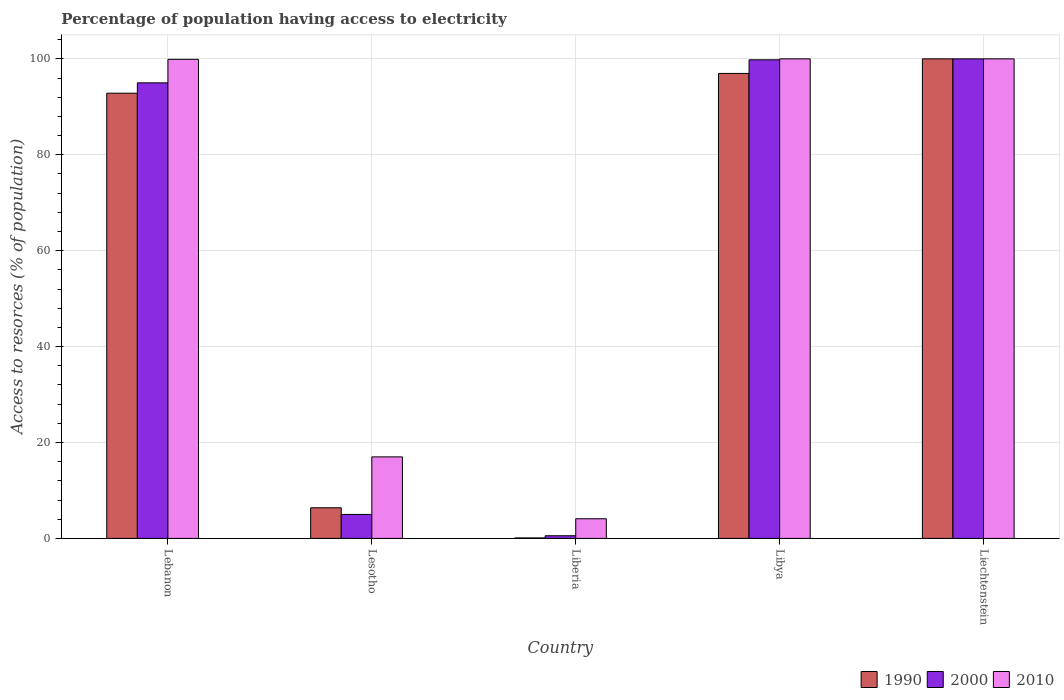How many different coloured bars are there?
Offer a terse response. 3. How many groups of bars are there?
Provide a short and direct response. 5. Are the number of bars per tick equal to the number of legend labels?
Your response must be concise. Yes. Are the number of bars on each tick of the X-axis equal?
Keep it short and to the point. Yes. How many bars are there on the 4th tick from the left?
Provide a succinct answer. 3. How many bars are there on the 4th tick from the right?
Keep it short and to the point. 3. What is the label of the 1st group of bars from the left?
Make the answer very short. Lebanon. What is the percentage of population having access to electricity in 1990 in Lesotho?
Offer a terse response. 6.39. Across all countries, what is the maximum percentage of population having access to electricity in 1990?
Keep it short and to the point. 100. Across all countries, what is the minimum percentage of population having access to electricity in 2010?
Make the answer very short. 4.1. In which country was the percentage of population having access to electricity in 1990 maximum?
Offer a very short reply. Liechtenstein. In which country was the percentage of population having access to electricity in 2000 minimum?
Provide a succinct answer. Liberia. What is the total percentage of population having access to electricity in 1990 in the graph?
Offer a terse response. 296.29. What is the difference between the percentage of population having access to electricity in 2010 in Lebanon and that in Lesotho?
Provide a succinct answer. 82.9. What is the average percentage of population having access to electricity in 1990 per country?
Provide a succinct answer. 59.26. What is the difference between the percentage of population having access to electricity of/in 1990 and percentage of population having access to electricity of/in 2000 in Lebanon?
Ensure brevity in your answer.  -2.16. In how many countries, is the percentage of population having access to electricity in 2000 greater than 56 %?
Provide a succinct answer. 3. What is the ratio of the percentage of population having access to electricity in 1990 in Lebanon to that in Lesotho?
Offer a very short reply. 14.53. Is the percentage of population having access to electricity in 2010 in Libya less than that in Liechtenstein?
Ensure brevity in your answer.  No. Is the difference between the percentage of population having access to electricity in 1990 in Lebanon and Lesotho greater than the difference between the percentage of population having access to electricity in 2000 in Lebanon and Lesotho?
Provide a short and direct response. No. What is the difference between the highest and the second highest percentage of population having access to electricity in 2010?
Make the answer very short. -0.1. What is the difference between the highest and the lowest percentage of population having access to electricity in 2010?
Your response must be concise. 95.9. Is the sum of the percentage of population having access to electricity in 1990 in Liberia and Libya greater than the maximum percentage of population having access to electricity in 2010 across all countries?
Provide a short and direct response. No. What does the 1st bar from the left in Lesotho represents?
Provide a succinct answer. 1990. What does the 2nd bar from the right in Liechtenstein represents?
Keep it short and to the point. 2000. Is it the case that in every country, the sum of the percentage of population having access to electricity in 1990 and percentage of population having access to electricity in 2000 is greater than the percentage of population having access to electricity in 2010?
Provide a short and direct response. No. How many bars are there?
Give a very brief answer. 15. Are all the bars in the graph horizontal?
Give a very brief answer. No. How many countries are there in the graph?
Your answer should be compact. 5. Are the values on the major ticks of Y-axis written in scientific E-notation?
Keep it short and to the point. No. How are the legend labels stacked?
Ensure brevity in your answer.  Horizontal. What is the title of the graph?
Ensure brevity in your answer.  Percentage of population having access to electricity. What is the label or title of the X-axis?
Give a very brief answer. Country. What is the label or title of the Y-axis?
Make the answer very short. Access to resorces (% of population). What is the Access to resorces (% of population) in 1990 in Lebanon?
Offer a terse response. 92.84. What is the Access to resorces (% of population) in 2010 in Lebanon?
Keep it short and to the point. 99.9. What is the Access to resorces (% of population) in 1990 in Lesotho?
Provide a succinct answer. 6.39. What is the Access to resorces (% of population) of 2000 in Lesotho?
Your response must be concise. 5. What is the Access to resorces (% of population) of 2010 in Lesotho?
Provide a short and direct response. 17. What is the Access to resorces (% of population) of 1990 in Liberia?
Your response must be concise. 0.1. What is the Access to resorces (% of population) of 2000 in Liberia?
Keep it short and to the point. 0.56. What is the Access to resorces (% of population) of 1990 in Libya?
Offer a very short reply. 96.96. What is the Access to resorces (% of population) in 2000 in Libya?
Your answer should be compact. 99.8. Across all countries, what is the maximum Access to resorces (% of population) in 1990?
Ensure brevity in your answer.  100. Across all countries, what is the minimum Access to resorces (% of population) of 1990?
Your answer should be compact. 0.1. Across all countries, what is the minimum Access to resorces (% of population) in 2000?
Provide a short and direct response. 0.56. Across all countries, what is the minimum Access to resorces (% of population) in 2010?
Offer a terse response. 4.1. What is the total Access to resorces (% of population) of 1990 in the graph?
Provide a succinct answer. 296.29. What is the total Access to resorces (% of population) of 2000 in the graph?
Your response must be concise. 300.36. What is the total Access to resorces (% of population) of 2010 in the graph?
Provide a short and direct response. 321. What is the difference between the Access to resorces (% of population) of 1990 in Lebanon and that in Lesotho?
Give a very brief answer. 86.45. What is the difference between the Access to resorces (% of population) in 2000 in Lebanon and that in Lesotho?
Your response must be concise. 90. What is the difference between the Access to resorces (% of population) of 2010 in Lebanon and that in Lesotho?
Ensure brevity in your answer.  82.9. What is the difference between the Access to resorces (% of population) in 1990 in Lebanon and that in Liberia?
Ensure brevity in your answer.  92.74. What is the difference between the Access to resorces (% of population) of 2000 in Lebanon and that in Liberia?
Give a very brief answer. 94.44. What is the difference between the Access to resorces (% of population) in 2010 in Lebanon and that in Liberia?
Your answer should be compact. 95.8. What is the difference between the Access to resorces (% of population) in 1990 in Lebanon and that in Libya?
Provide a short and direct response. -4.12. What is the difference between the Access to resorces (% of population) of 1990 in Lebanon and that in Liechtenstein?
Provide a short and direct response. -7.16. What is the difference between the Access to resorces (% of population) in 2000 in Lebanon and that in Liechtenstein?
Make the answer very short. -5. What is the difference between the Access to resorces (% of population) of 1990 in Lesotho and that in Liberia?
Your answer should be very brief. 6.29. What is the difference between the Access to resorces (% of population) of 2000 in Lesotho and that in Liberia?
Make the answer very short. 4.44. What is the difference between the Access to resorces (% of population) of 2010 in Lesotho and that in Liberia?
Your answer should be compact. 12.9. What is the difference between the Access to resorces (% of population) of 1990 in Lesotho and that in Libya?
Ensure brevity in your answer.  -90.57. What is the difference between the Access to resorces (% of population) of 2000 in Lesotho and that in Libya?
Offer a terse response. -94.8. What is the difference between the Access to resorces (% of population) of 2010 in Lesotho and that in Libya?
Your answer should be compact. -83. What is the difference between the Access to resorces (% of population) of 1990 in Lesotho and that in Liechtenstein?
Provide a short and direct response. -93.61. What is the difference between the Access to resorces (% of population) in 2000 in Lesotho and that in Liechtenstein?
Provide a short and direct response. -95. What is the difference between the Access to resorces (% of population) of 2010 in Lesotho and that in Liechtenstein?
Your answer should be very brief. -83. What is the difference between the Access to resorces (% of population) of 1990 in Liberia and that in Libya?
Ensure brevity in your answer.  -96.86. What is the difference between the Access to resorces (% of population) of 2000 in Liberia and that in Libya?
Provide a short and direct response. -99.24. What is the difference between the Access to resorces (% of population) of 2010 in Liberia and that in Libya?
Make the answer very short. -95.9. What is the difference between the Access to resorces (% of population) of 1990 in Liberia and that in Liechtenstein?
Ensure brevity in your answer.  -99.9. What is the difference between the Access to resorces (% of population) in 2000 in Liberia and that in Liechtenstein?
Provide a succinct answer. -99.44. What is the difference between the Access to resorces (% of population) in 2010 in Liberia and that in Liechtenstein?
Provide a short and direct response. -95.9. What is the difference between the Access to resorces (% of population) in 1990 in Libya and that in Liechtenstein?
Ensure brevity in your answer.  -3.04. What is the difference between the Access to resorces (% of population) in 2000 in Libya and that in Liechtenstein?
Offer a terse response. -0.2. What is the difference between the Access to resorces (% of population) of 2010 in Libya and that in Liechtenstein?
Your response must be concise. 0. What is the difference between the Access to resorces (% of population) in 1990 in Lebanon and the Access to resorces (% of population) in 2000 in Lesotho?
Your answer should be compact. 87.84. What is the difference between the Access to resorces (% of population) of 1990 in Lebanon and the Access to resorces (% of population) of 2010 in Lesotho?
Make the answer very short. 75.84. What is the difference between the Access to resorces (% of population) of 1990 in Lebanon and the Access to resorces (% of population) of 2000 in Liberia?
Keep it short and to the point. 92.28. What is the difference between the Access to resorces (% of population) of 1990 in Lebanon and the Access to resorces (% of population) of 2010 in Liberia?
Ensure brevity in your answer.  88.74. What is the difference between the Access to resorces (% of population) of 2000 in Lebanon and the Access to resorces (% of population) of 2010 in Liberia?
Provide a succinct answer. 90.9. What is the difference between the Access to resorces (% of population) of 1990 in Lebanon and the Access to resorces (% of population) of 2000 in Libya?
Your response must be concise. -6.96. What is the difference between the Access to resorces (% of population) in 1990 in Lebanon and the Access to resorces (% of population) in 2010 in Libya?
Offer a terse response. -7.16. What is the difference between the Access to resorces (% of population) of 1990 in Lebanon and the Access to resorces (% of population) of 2000 in Liechtenstein?
Your answer should be compact. -7.16. What is the difference between the Access to resorces (% of population) of 1990 in Lebanon and the Access to resorces (% of population) of 2010 in Liechtenstein?
Offer a terse response. -7.16. What is the difference between the Access to resorces (% of population) of 2000 in Lebanon and the Access to resorces (% of population) of 2010 in Liechtenstein?
Provide a short and direct response. -5. What is the difference between the Access to resorces (% of population) in 1990 in Lesotho and the Access to resorces (% of population) in 2000 in Liberia?
Provide a short and direct response. 5.83. What is the difference between the Access to resorces (% of population) of 1990 in Lesotho and the Access to resorces (% of population) of 2010 in Liberia?
Your response must be concise. 2.29. What is the difference between the Access to resorces (% of population) in 1990 in Lesotho and the Access to resorces (% of population) in 2000 in Libya?
Keep it short and to the point. -93.41. What is the difference between the Access to resorces (% of population) in 1990 in Lesotho and the Access to resorces (% of population) in 2010 in Libya?
Ensure brevity in your answer.  -93.61. What is the difference between the Access to resorces (% of population) of 2000 in Lesotho and the Access to resorces (% of population) of 2010 in Libya?
Your answer should be very brief. -95. What is the difference between the Access to resorces (% of population) in 1990 in Lesotho and the Access to resorces (% of population) in 2000 in Liechtenstein?
Give a very brief answer. -93.61. What is the difference between the Access to resorces (% of population) of 1990 in Lesotho and the Access to resorces (% of population) of 2010 in Liechtenstein?
Provide a short and direct response. -93.61. What is the difference between the Access to resorces (% of population) of 2000 in Lesotho and the Access to resorces (% of population) of 2010 in Liechtenstein?
Your response must be concise. -95. What is the difference between the Access to resorces (% of population) of 1990 in Liberia and the Access to resorces (% of population) of 2000 in Libya?
Provide a succinct answer. -99.7. What is the difference between the Access to resorces (% of population) in 1990 in Liberia and the Access to resorces (% of population) in 2010 in Libya?
Provide a short and direct response. -99.9. What is the difference between the Access to resorces (% of population) of 2000 in Liberia and the Access to resorces (% of population) of 2010 in Libya?
Provide a succinct answer. -99.44. What is the difference between the Access to resorces (% of population) of 1990 in Liberia and the Access to resorces (% of population) of 2000 in Liechtenstein?
Keep it short and to the point. -99.9. What is the difference between the Access to resorces (% of population) in 1990 in Liberia and the Access to resorces (% of population) in 2010 in Liechtenstein?
Your response must be concise. -99.9. What is the difference between the Access to resorces (% of population) of 2000 in Liberia and the Access to resorces (% of population) of 2010 in Liechtenstein?
Provide a succinct answer. -99.44. What is the difference between the Access to resorces (% of population) in 1990 in Libya and the Access to resorces (% of population) in 2000 in Liechtenstein?
Your answer should be very brief. -3.04. What is the difference between the Access to resorces (% of population) of 1990 in Libya and the Access to resorces (% of population) of 2010 in Liechtenstein?
Your answer should be very brief. -3.04. What is the average Access to resorces (% of population) in 1990 per country?
Offer a terse response. 59.26. What is the average Access to resorces (% of population) in 2000 per country?
Provide a short and direct response. 60.07. What is the average Access to resorces (% of population) of 2010 per country?
Keep it short and to the point. 64.2. What is the difference between the Access to resorces (% of population) of 1990 and Access to resorces (% of population) of 2000 in Lebanon?
Your answer should be compact. -2.16. What is the difference between the Access to resorces (% of population) of 1990 and Access to resorces (% of population) of 2010 in Lebanon?
Make the answer very short. -7.06. What is the difference between the Access to resorces (% of population) of 1990 and Access to resorces (% of population) of 2000 in Lesotho?
Provide a short and direct response. 1.39. What is the difference between the Access to resorces (% of population) of 1990 and Access to resorces (% of population) of 2010 in Lesotho?
Make the answer very short. -10.61. What is the difference between the Access to resorces (% of population) in 2000 and Access to resorces (% of population) in 2010 in Lesotho?
Keep it short and to the point. -12. What is the difference between the Access to resorces (% of population) in 1990 and Access to resorces (% of population) in 2000 in Liberia?
Give a very brief answer. -0.46. What is the difference between the Access to resorces (% of population) of 1990 and Access to resorces (% of population) of 2010 in Liberia?
Ensure brevity in your answer.  -4. What is the difference between the Access to resorces (% of population) in 2000 and Access to resorces (% of population) in 2010 in Liberia?
Keep it short and to the point. -3.54. What is the difference between the Access to resorces (% of population) in 1990 and Access to resorces (% of population) in 2000 in Libya?
Your response must be concise. -2.84. What is the difference between the Access to resorces (% of population) of 1990 and Access to resorces (% of population) of 2010 in Libya?
Give a very brief answer. -3.04. What is the difference between the Access to resorces (% of population) of 2000 and Access to resorces (% of population) of 2010 in Libya?
Offer a very short reply. -0.2. What is the difference between the Access to resorces (% of population) in 1990 and Access to resorces (% of population) in 2010 in Liechtenstein?
Give a very brief answer. 0. What is the difference between the Access to resorces (% of population) of 2000 and Access to resorces (% of population) of 2010 in Liechtenstein?
Your answer should be very brief. 0. What is the ratio of the Access to resorces (% of population) of 1990 in Lebanon to that in Lesotho?
Make the answer very short. 14.53. What is the ratio of the Access to resorces (% of population) of 2010 in Lebanon to that in Lesotho?
Offer a very short reply. 5.88. What is the ratio of the Access to resorces (% of population) in 1990 in Lebanon to that in Liberia?
Provide a succinct answer. 928.38. What is the ratio of the Access to resorces (% of population) of 2000 in Lebanon to that in Liberia?
Offer a terse response. 170.91. What is the ratio of the Access to resorces (% of population) in 2010 in Lebanon to that in Liberia?
Offer a terse response. 24.37. What is the ratio of the Access to resorces (% of population) in 1990 in Lebanon to that in Libya?
Your answer should be very brief. 0.96. What is the ratio of the Access to resorces (% of population) of 2000 in Lebanon to that in Libya?
Provide a short and direct response. 0.95. What is the ratio of the Access to resorces (% of population) in 2010 in Lebanon to that in Libya?
Offer a terse response. 1. What is the ratio of the Access to resorces (% of population) in 1990 in Lebanon to that in Liechtenstein?
Keep it short and to the point. 0.93. What is the ratio of the Access to resorces (% of population) in 1990 in Lesotho to that in Liberia?
Provide a short and direct response. 63.88. What is the ratio of the Access to resorces (% of population) of 2000 in Lesotho to that in Liberia?
Provide a short and direct response. 9. What is the ratio of the Access to resorces (% of population) in 2010 in Lesotho to that in Liberia?
Your response must be concise. 4.15. What is the ratio of the Access to resorces (% of population) in 1990 in Lesotho to that in Libya?
Offer a terse response. 0.07. What is the ratio of the Access to resorces (% of population) of 2000 in Lesotho to that in Libya?
Give a very brief answer. 0.05. What is the ratio of the Access to resorces (% of population) of 2010 in Lesotho to that in Libya?
Ensure brevity in your answer.  0.17. What is the ratio of the Access to resorces (% of population) in 1990 in Lesotho to that in Liechtenstein?
Offer a terse response. 0.06. What is the ratio of the Access to resorces (% of population) of 2000 in Lesotho to that in Liechtenstein?
Make the answer very short. 0.05. What is the ratio of the Access to resorces (% of population) in 2010 in Lesotho to that in Liechtenstein?
Your answer should be very brief. 0.17. What is the ratio of the Access to resorces (% of population) in 1990 in Liberia to that in Libya?
Provide a short and direct response. 0. What is the ratio of the Access to resorces (% of population) in 2000 in Liberia to that in Libya?
Your answer should be compact. 0.01. What is the ratio of the Access to resorces (% of population) in 2010 in Liberia to that in Libya?
Offer a very short reply. 0.04. What is the ratio of the Access to resorces (% of population) in 1990 in Liberia to that in Liechtenstein?
Make the answer very short. 0. What is the ratio of the Access to resorces (% of population) in 2000 in Liberia to that in Liechtenstein?
Give a very brief answer. 0.01. What is the ratio of the Access to resorces (% of population) of 2010 in Liberia to that in Liechtenstein?
Make the answer very short. 0.04. What is the ratio of the Access to resorces (% of population) of 1990 in Libya to that in Liechtenstein?
Give a very brief answer. 0.97. What is the ratio of the Access to resorces (% of population) of 2010 in Libya to that in Liechtenstein?
Your answer should be compact. 1. What is the difference between the highest and the second highest Access to resorces (% of population) in 1990?
Offer a terse response. 3.04. What is the difference between the highest and the second highest Access to resorces (% of population) of 2010?
Your response must be concise. 0. What is the difference between the highest and the lowest Access to resorces (% of population) of 1990?
Your answer should be very brief. 99.9. What is the difference between the highest and the lowest Access to resorces (% of population) in 2000?
Offer a terse response. 99.44. What is the difference between the highest and the lowest Access to resorces (% of population) in 2010?
Your answer should be very brief. 95.9. 